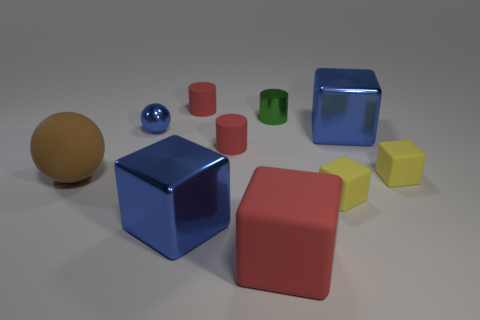Subtract all rubber cylinders. How many cylinders are left? 1 Subtract 2 balls. How many balls are left? 0 Subtract all blue balls. How many balls are left? 1 Subtract all green metallic cylinders. Subtract all tiny blue things. How many objects are left? 8 Add 2 big blue metal cubes. How many big blue metal cubes are left? 4 Add 4 brown rubber objects. How many brown rubber objects exist? 5 Subtract 2 yellow blocks. How many objects are left? 8 Subtract all spheres. How many objects are left? 8 Subtract all green blocks. Subtract all blue spheres. How many blocks are left? 5 Subtract all green cubes. How many green cylinders are left? 1 